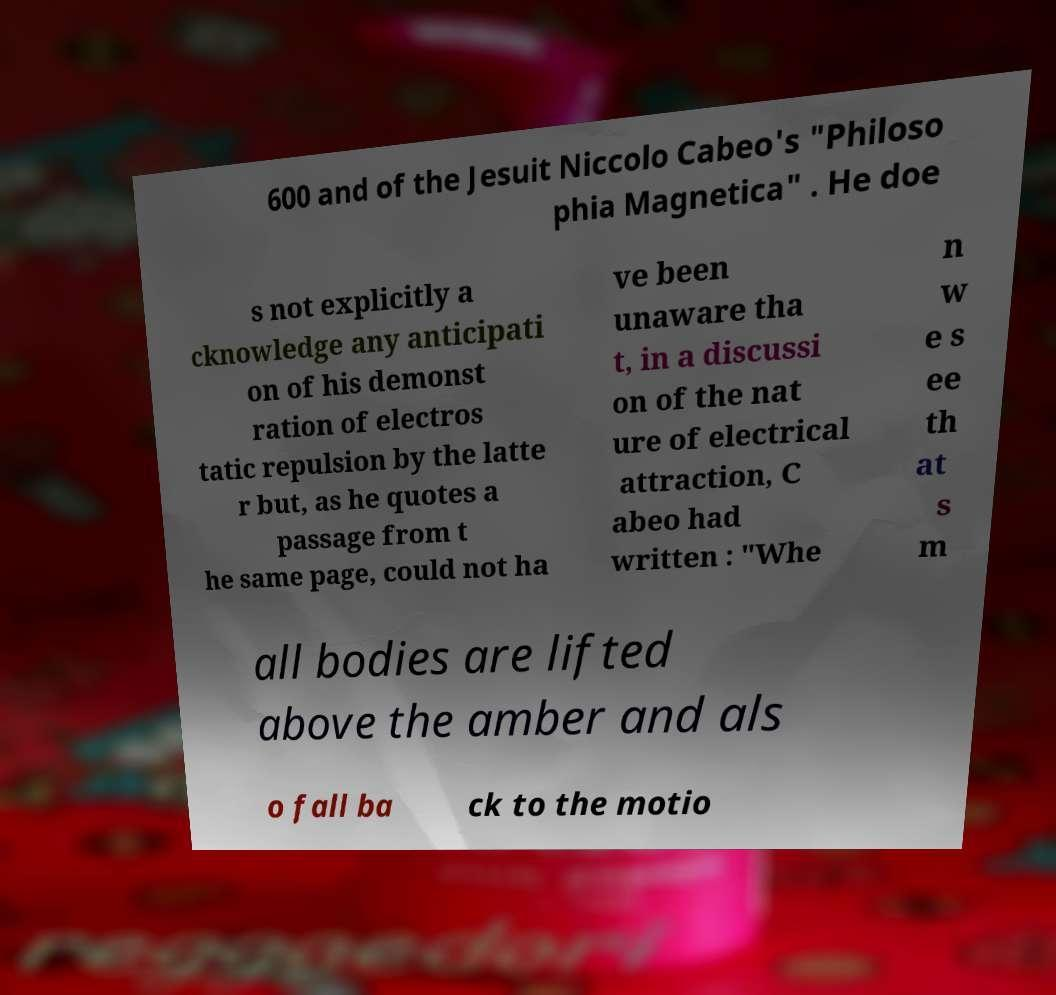What messages or text are displayed in this image? I need them in a readable, typed format. 600 and of the Jesuit Niccolo Cabeo's "Philoso phia Magnetica" . He doe s not explicitly a cknowledge any anticipati on of his demonst ration of electros tatic repulsion by the latte r but, as he quotes a passage from t he same page, could not ha ve been unaware tha t, in a discussi on of the nat ure of electrical attraction, C abeo had written : "Whe n w e s ee th at s m all bodies are lifted above the amber and als o fall ba ck to the motio 